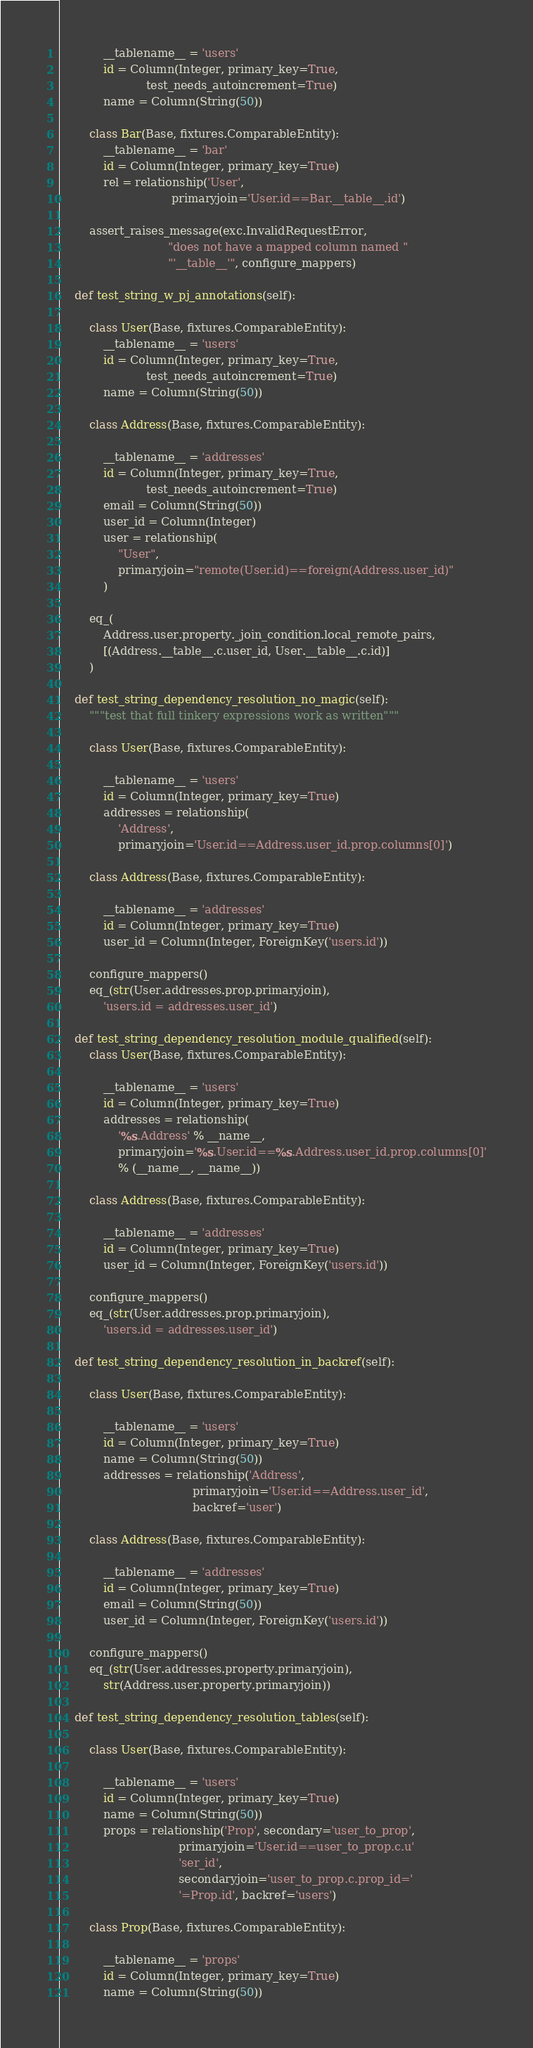<code> <loc_0><loc_0><loc_500><loc_500><_Python_>            __tablename__ = 'users'
            id = Column(Integer, primary_key=True,
                        test_needs_autoincrement=True)
            name = Column(String(50))

        class Bar(Base, fixtures.ComparableEntity):
            __tablename__ = 'bar'
            id = Column(Integer, primary_key=True)
            rel = relationship('User',
                               primaryjoin='User.id==Bar.__table__.id')

        assert_raises_message(exc.InvalidRequestError,
                              "does not have a mapped column named "
                              "'__table__'", configure_mappers)

    def test_string_w_pj_annotations(self):

        class User(Base, fixtures.ComparableEntity):
            __tablename__ = 'users'
            id = Column(Integer, primary_key=True,
                        test_needs_autoincrement=True)
            name = Column(String(50))

        class Address(Base, fixtures.ComparableEntity):

            __tablename__ = 'addresses'
            id = Column(Integer, primary_key=True,
                        test_needs_autoincrement=True)
            email = Column(String(50))
            user_id = Column(Integer)
            user = relationship(
                "User",
                primaryjoin="remote(User.id)==foreign(Address.user_id)"
            )

        eq_(
            Address.user.property._join_condition.local_remote_pairs,
            [(Address.__table__.c.user_id, User.__table__.c.id)]
        )

    def test_string_dependency_resolution_no_magic(self):
        """test that full tinkery expressions work as written"""

        class User(Base, fixtures.ComparableEntity):

            __tablename__ = 'users'
            id = Column(Integer, primary_key=True)
            addresses = relationship(
                'Address',
                primaryjoin='User.id==Address.user_id.prop.columns[0]')

        class Address(Base, fixtures.ComparableEntity):

            __tablename__ = 'addresses'
            id = Column(Integer, primary_key=True)
            user_id = Column(Integer, ForeignKey('users.id'))

        configure_mappers()
        eq_(str(User.addresses.prop.primaryjoin),
            'users.id = addresses.user_id')

    def test_string_dependency_resolution_module_qualified(self):
        class User(Base, fixtures.ComparableEntity):

            __tablename__ = 'users'
            id = Column(Integer, primary_key=True)
            addresses = relationship(
                '%s.Address' % __name__,
                primaryjoin='%s.User.id==%s.Address.user_id.prop.columns[0]'
                % (__name__, __name__))

        class Address(Base, fixtures.ComparableEntity):

            __tablename__ = 'addresses'
            id = Column(Integer, primary_key=True)
            user_id = Column(Integer, ForeignKey('users.id'))

        configure_mappers()
        eq_(str(User.addresses.prop.primaryjoin),
            'users.id = addresses.user_id')

    def test_string_dependency_resolution_in_backref(self):

        class User(Base, fixtures.ComparableEntity):

            __tablename__ = 'users'
            id = Column(Integer, primary_key=True)
            name = Column(String(50))
            addresses = relationship('Address',
                                     primaryjoin='User.id==Address.user_id',
                                     backref='user')

        class Address(Base, fixtures.ComparableEntity):

            __tablename__ = 'addresses'
            id = Column(Integer, primary_key=True)
            email = Column(String(50))
            user_id = Column(Integer, ForeignKey('users.id'))

        configure_mappers()
        eq_(str(User.addresses.property.primaryjoin),
            str(Address.user.property.primaryjoin))

    def test_string_dependency_resolution_tables(self):

        class User(Base, fixtures.ComparableEntity):

            __tablename__ = 'users'
            id = Column(Integer, primary_key=True)
            name = Column(String(50))
            props = relationship('Prop', secondary='user_to_prop',
                                 primaryjoin='User.id==user_to_prop.c.u'
                                 'ser_id',
                                 secondaryjoin='user_to_prop.c.prop_id='
                                 '=Prop.id', backref='users')

        class Prop(Base, fixtures.ComparableEntity):

            __tablename__ = 'props'
            id = Column(Integer, primary_key=True)
            name = Column(String(50))
</code> 